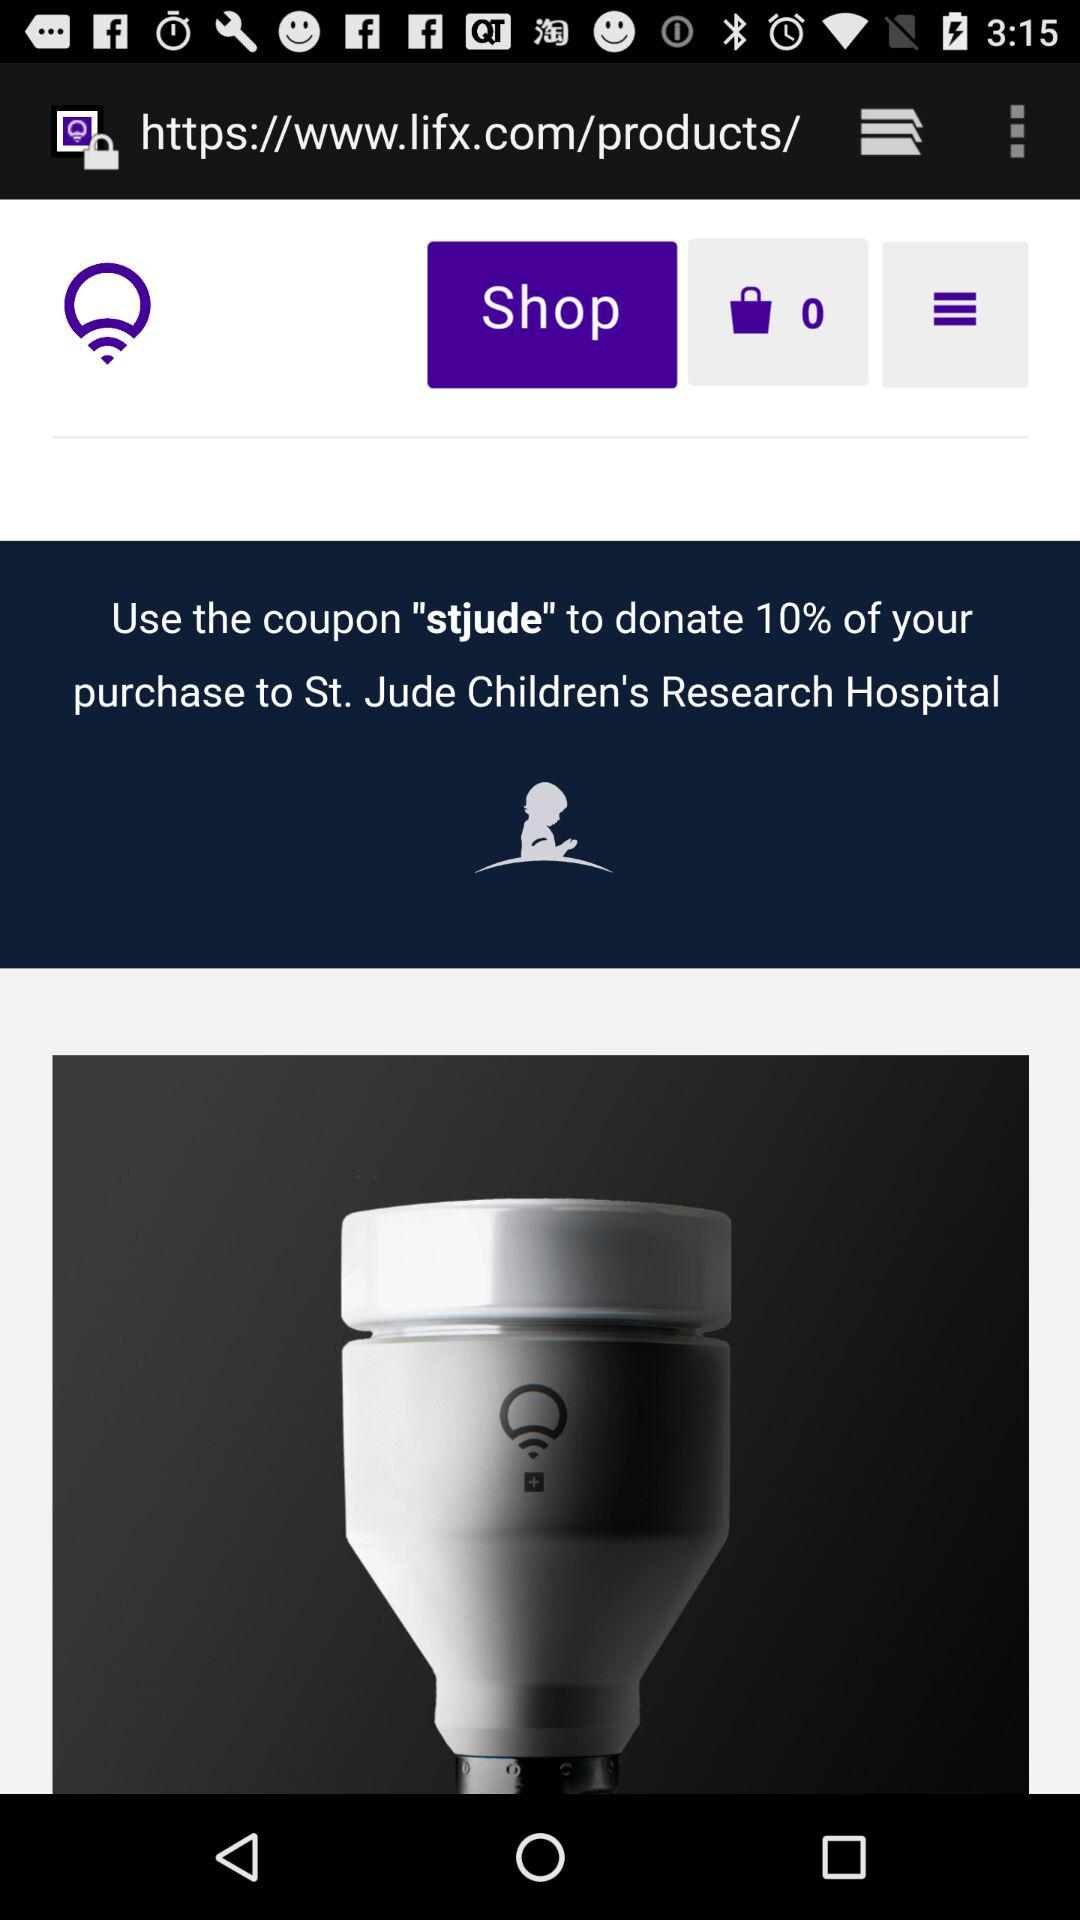How many items are in the bag? There are 0 items in the bag. 